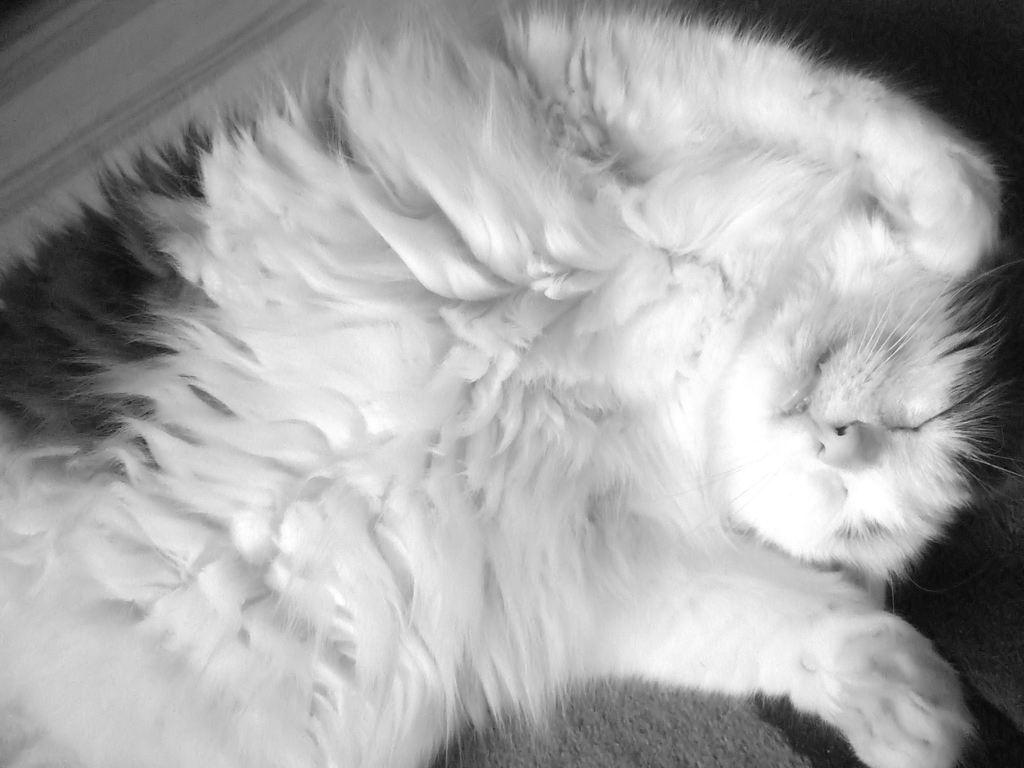What type of animal is in the image? There is a cat in the image. What is the cat doing in the image? The cat is sleeping. What colors can be seen on the cat in the image? The cat is white and black in color. What type of hook can be seen in the image? There is no hook present in the image. What type of range can be seen in the image? There is no range present in the image. What type of prose can be read in the image? There is no prose present in the image. 